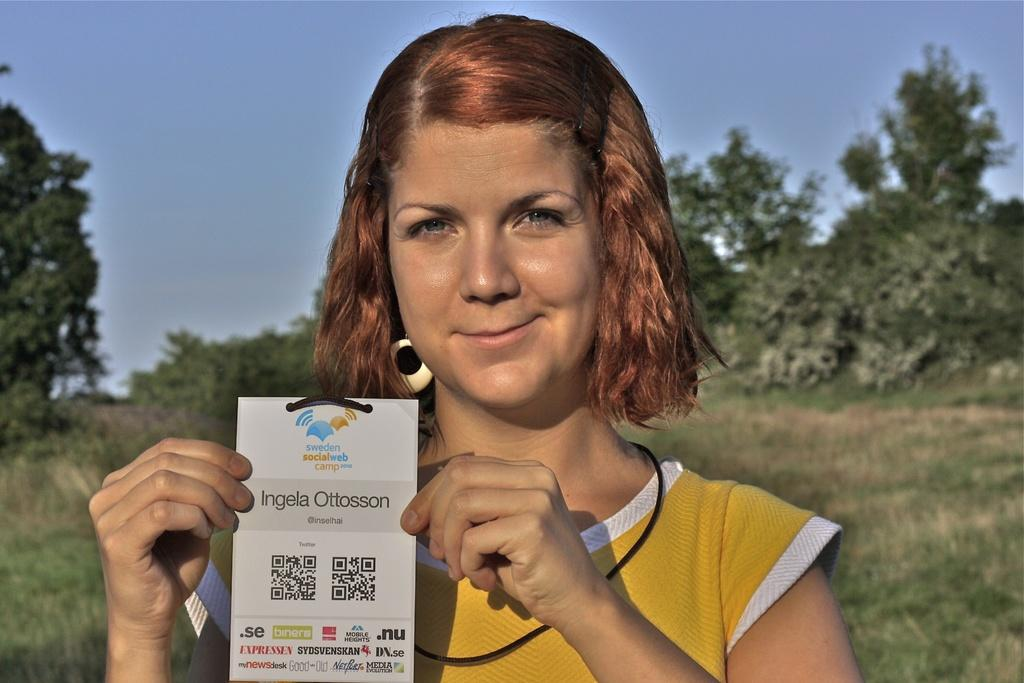Who is the main subject in the image? There is a lady in the image. What is the lady wearing in the image? The lady is wearing a tag in the image. How is the lady holding the tag? The lady is holding the tag in her hand. What can be seen on the tag? There is writing on the tag. What is visible in the background of the image? Trees and the sky are visible in the background of the image. What type of ground is present in the image? There is grass on the ground in the image. How many brothers does the lady have, and are they present in the image? There is no information about the lady's brothers in the image, nor are they visible. Can you tell me if the ant is carrying any food in the image? There is no ant present in the image, so it cannot be determined if it is carrying any food. 